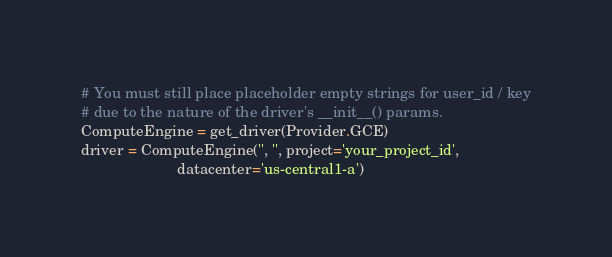Convert code to text. <code><loc_0><loc_0><loc_500><loc_500><_Python_># You must still place placeholder empty strings for user_id / key
# due to the nature of the driver's __init__() params.
ComputeEngine = get_driver(Provider.GCE)
driver = ComputeEngine('', '', project='your_project_id',
                       datacenter='us-central1-a')
</code> 